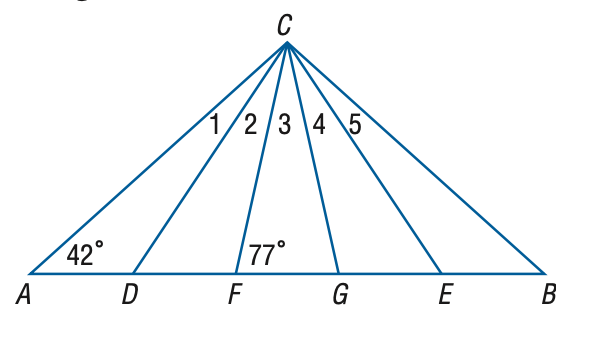Answer the mathemtical geometry problem and directly provide the correct option letter.
Question: In the figure, \triangle A B C is isosceles, \triangle D C E is equilateral, and \triangle F C G is isosceles. Find the measure of the \angle 5 at vertex C.
Choices: A: 15 B: 16 C: 17 D: 18 D 